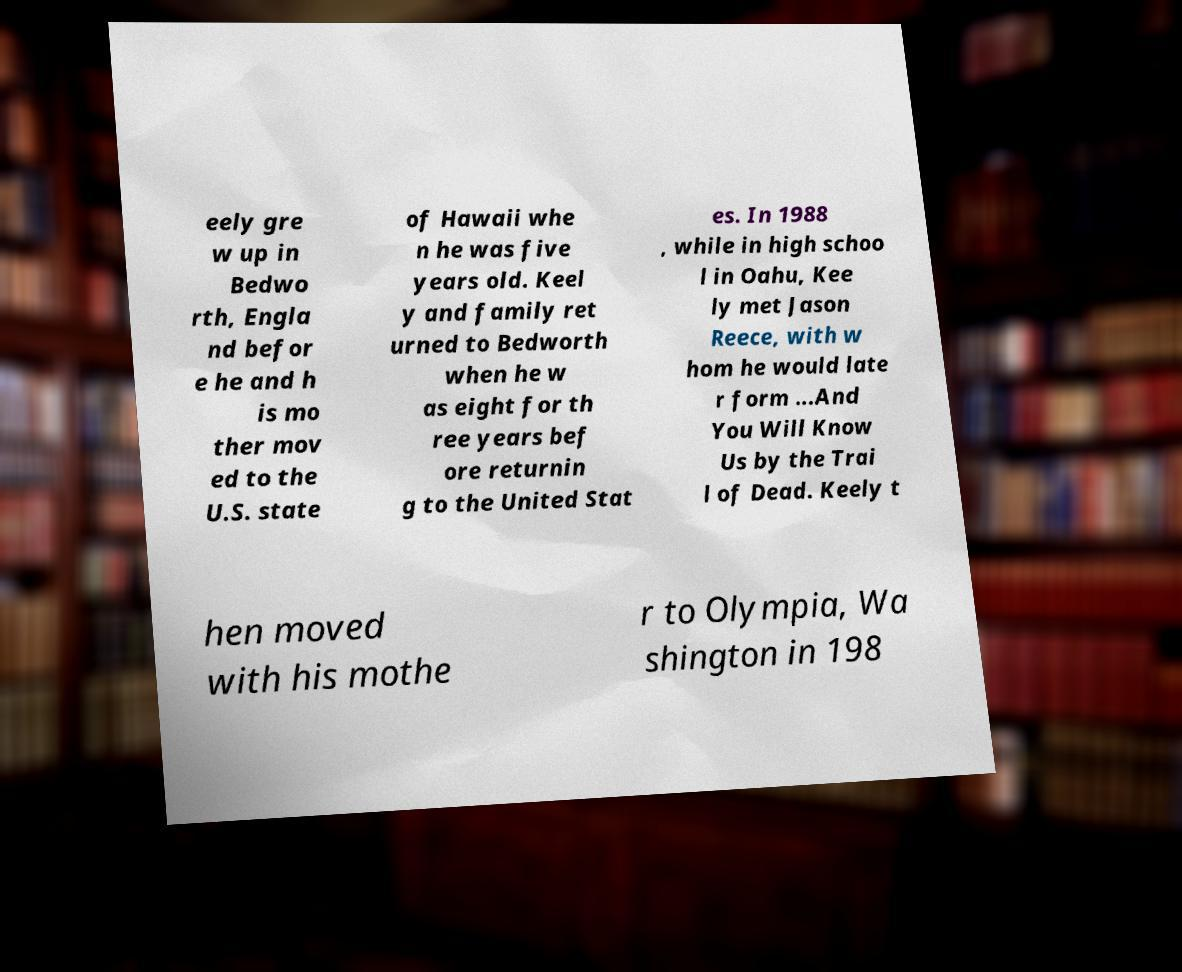Please read and relay the text visible in this image. What does it say? eely gre w up in Bedwo rth, Engla nd befor e he and h is mo ther mov ed to the U.S. state of Hawaii whe n he was five years old. Keel y and family ret urned to Bedworth when he w as eight for th ree years bef ore returnin g to the United Stat es. In 1988 , while in high schoo l in Oahu, Kee ly met Jason Reece, with w hom he would late r form ...And You Will Know Us by the Trai l of Dead. Keely t hen moved with his mothe r to Olympia, Wa shington in 198 